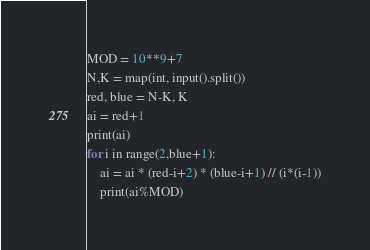Convert code to text. <code><loc_0><loc_0><loc_500><loc_500><_Python_>MOD = 10**9+7
N,K = map(int, input().split())
red, blue = N-K, K
ai = red+1
print(ai)
for i in range(2,blue+1):
    ai = ai * (red-i+2) * (blue-i+1) // (i*(i-1))
    print(ai%MOD)</code> 